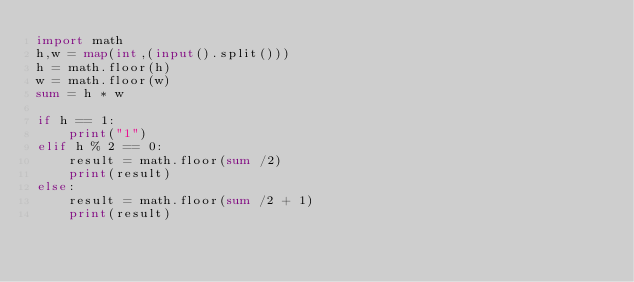Convert code to text. <code><loc_0><loc_0><loc_500><loc_500><_Python_>import math
h,w = map(int,(input().split()))
h = math.floor(h)
w = math.floor(w)
sum = h * w

if h == 1:
    print("1")
elif h % 2 == 0:
    result = math.floor(sum /2)
    print(result)
else:
    result = math.floor(sum /2 + 1)
    print(result)</code> 